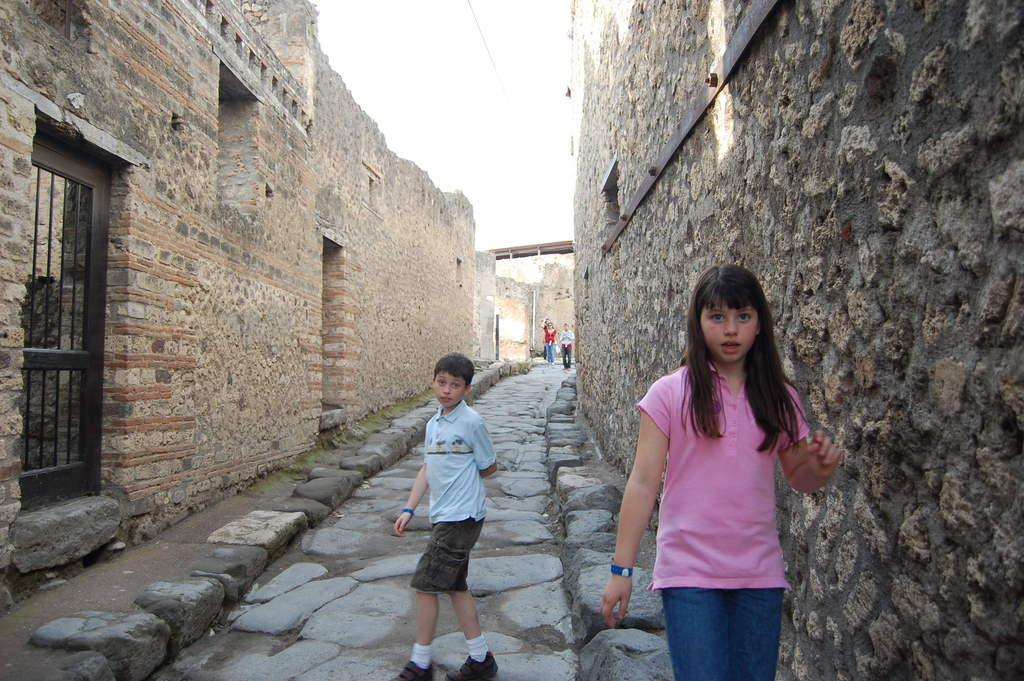How many people are visible in the image? There are two people, a girl and a boy, standing in the image. What is the background of the image? The image appears to be taken in front of a building wall. What architectural feature can be seen in the image? There is an iron gate in the image. Are there any other people visible in the image? Yes, there are people standing in the background of the image. What type of pathway is visible in the image? There is a pathway visible in the image. What type of seafood is being served at the feast in the image? There is no feast or seafood present in the image; it features a girl and a boy standing in front of a building wall with an iron gate and people in the background. What type of knife is being used by the person in the image? There is no knife or person using a knife present in the image. 